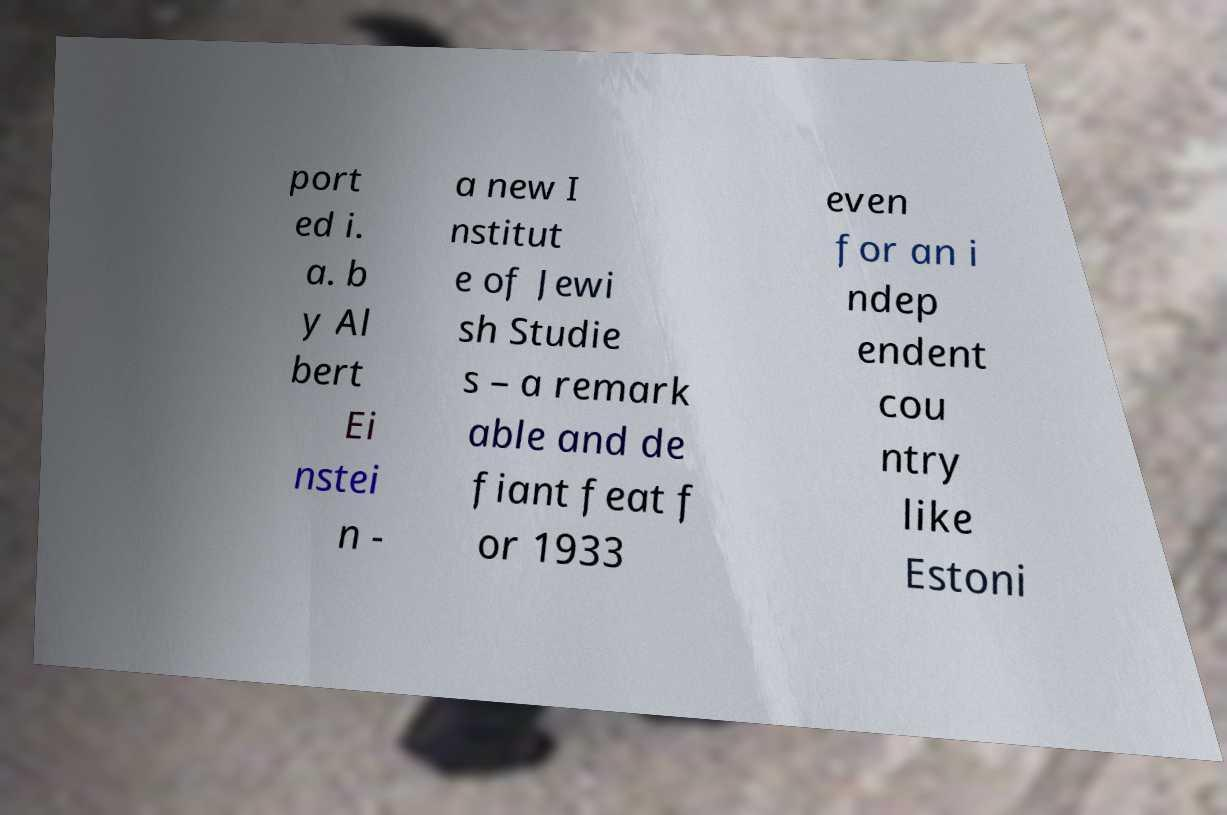Please read and relay the text visible in this image. What does it say? port ed i. a. b y Al bert Ei nstei n - a new I nstitut e of Jewi sh Studie s – a remark able and de fiant feat f or 1933 even for an i ndep endent cou ntry like Estoni 